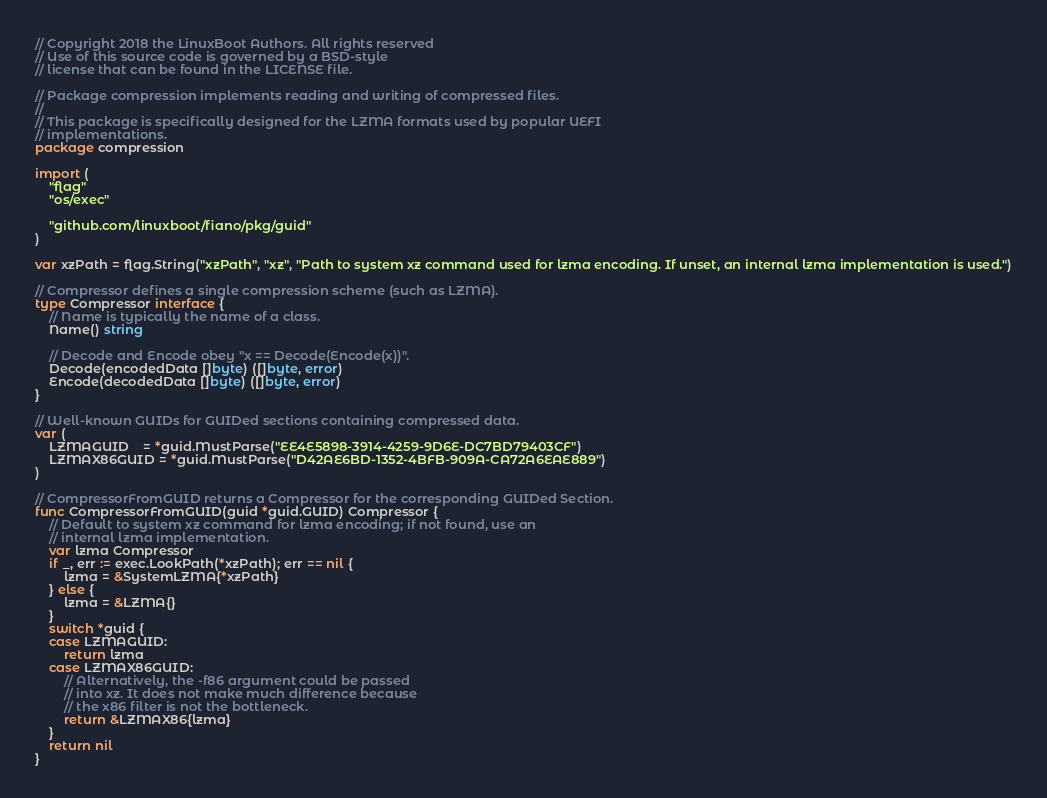Convert code to text. <code><loc_0><loc_0><loc_500><loc_500><_Go_>// Copyright 2018 the LinuxBoot Authors. All rights reserved
// Use of this source code is governed by a BSD-style
// license that can be found in the LICENSE file.

// Package compression implements reading and writing of compressed files.
//
// This package is specifically designed for the LZMA formats used by popular UEFI
// implementations.
package compression

import (
	"flag"
	"os/exec"

	"github.com/linuxboot/fiano/pkg/guid"
)

var xzPath = flag.String("xzPath", "xz", "Path to system xz command used for lzma encoding. If unset, an internal lzma implementation is used.")

// Compressor defines a single compression scheme (such as LZMA).
type Compressor interface {
	// Name is typically the name of a class.
	Name() string

	// Decode and Encode obey "x == Decode(Encode(x))".
	Decode(encodedData []byte) ([]byte, error)
	Encode(decodedData []byte) ([]byte, error)
}

// Well-known GUIDs for GUIDed sections containing compressed data.
var (
	LZMAGUID    = *guid.MustParse("EE4E5898-3914-4259-9D6E-DC7BD79403CF")
	LZMAX86GUID = *guid.MustParse("D42AE6BD-1352-4BFB-909A-CA72A6EAE889")
)

// CompressorFromGUID returns a Compressor for the corresponding GUIDed Section.
func CompressorFromGUID(guid *guid.GUID) Compressor {
	// Default to system xz command for lzma encoding; if not found, use an
	// internal lzma implementation.
	var lzma Compressor
	if _, err := exec.LookPath(*xzPath); err == nil {
		lzma = &SystemLZMA{*xzPath}
	} else {
		lzma = &LZMA{}
	}
	switch *guid {
	case LZMAGUID:
		return lzma
	case LZMAX86GUID:
		// Alternatively, the -f86 argument could be passed
		// into xz. It does not make much difference because
		// the x86 filter is not the bottleneck.
		return &LZMAX86{lzma}
	}
	return nil
}
</code> 